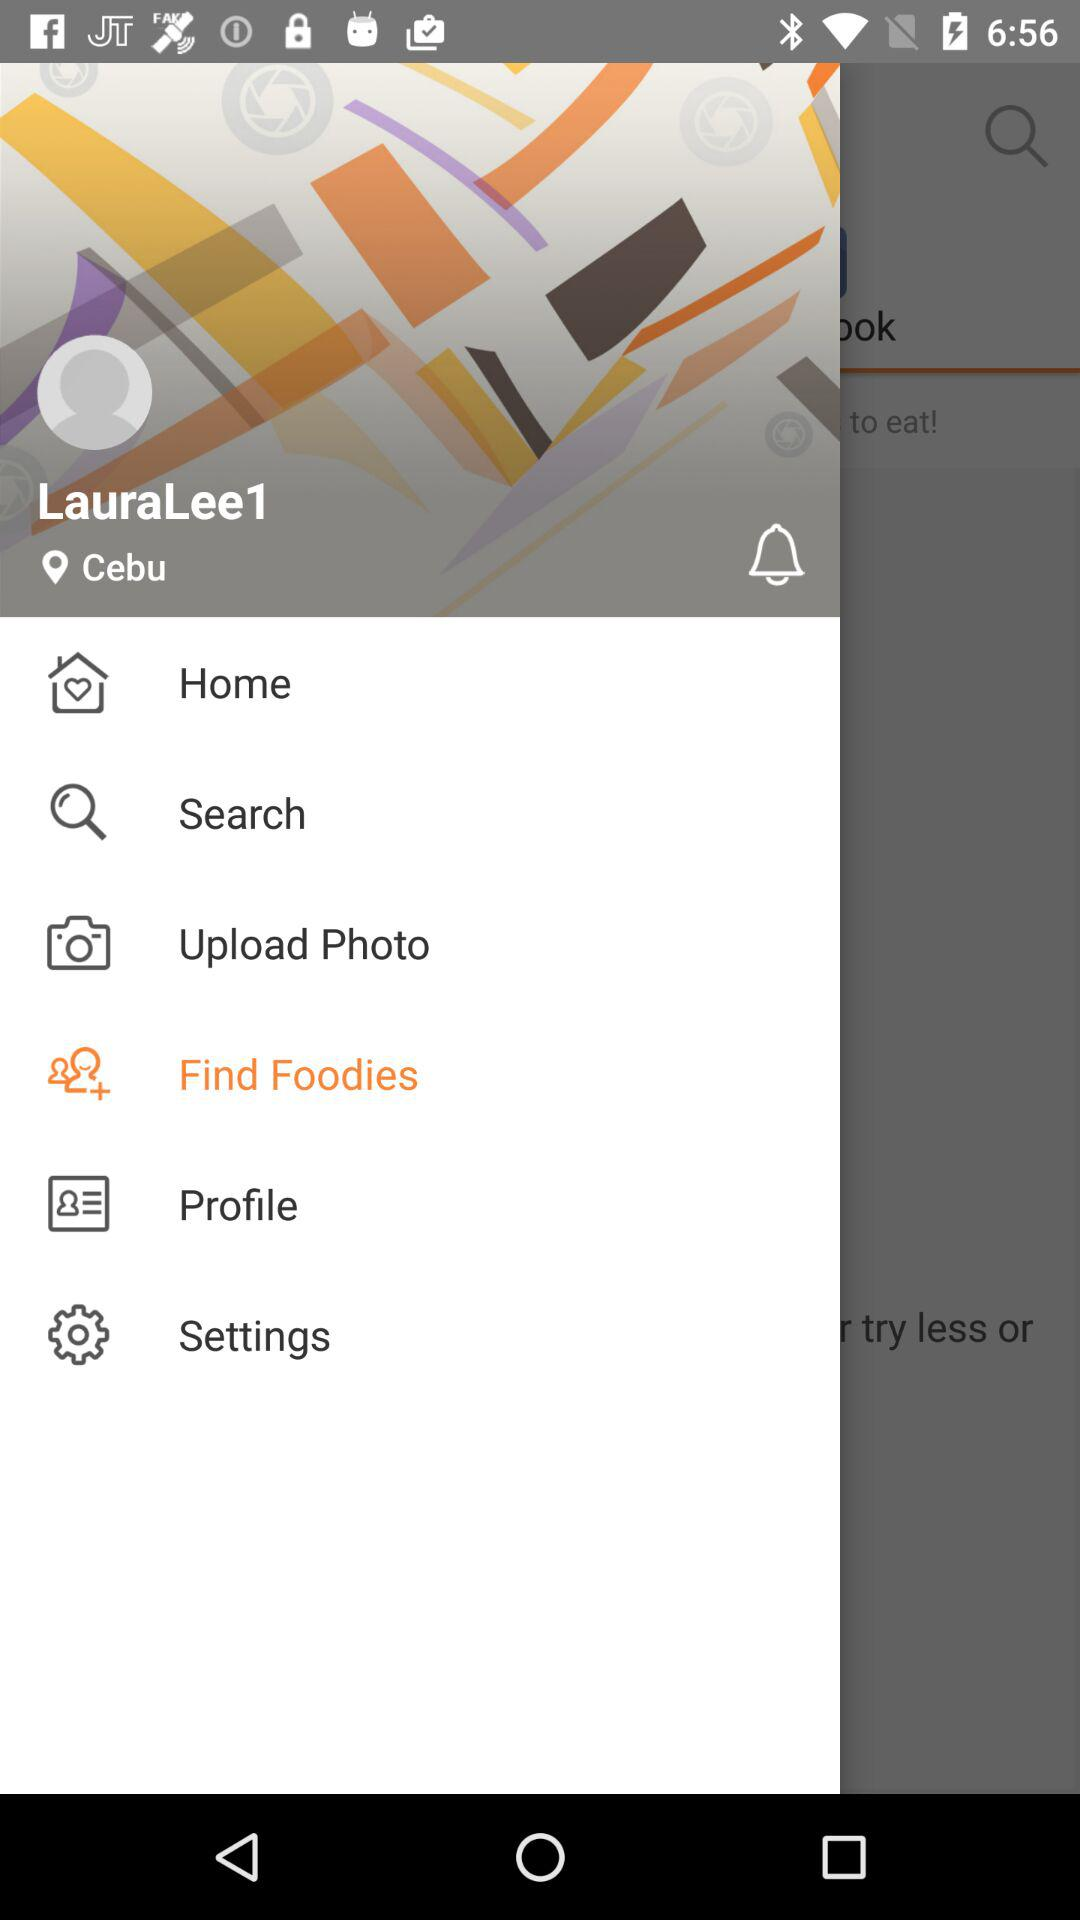What is the username? The username is "LauraLee1". 